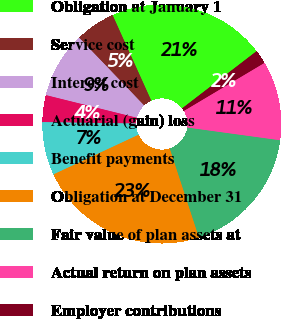Convert chart to OTSL. <chart><loc_0><loc_0><loc_500><loc_500><pie_chart><fcel>Obligation at January 1<fcel>Service cost<fcel>Interest cost<fcel>Actuarial (gain) loss<fcel>Benefit payments<fcel>Obligation at December 31<fcel>Fair value of plan assets at<fcel>Actual return on plan assets<fcel>Employer contributions<nl><fcel>21.33%<fcel>5.41%<fcel>8.95%<fcel>3.64%<fcel>7.18%<fcel>23.1%<fcel>17.79%<fcel>10.72%<fcel>1.87%<nl></chart> 